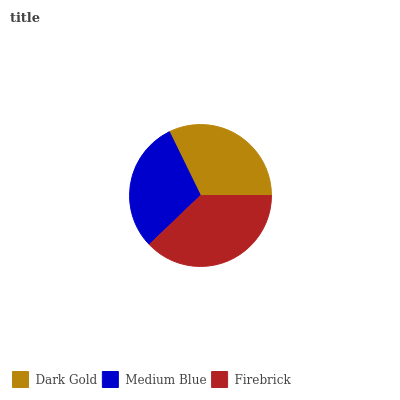Is Medium Blue the minimum?
Answer yes or no. Yes. Is Firebrick the maximum?
Answer yes or no. Yes. Is Firebrick the minimum?
Answer yes or no. No. Is Medium Blue the maximum?
Answer yes or no. No. Is Firebrick greater than Medium Blue?
Answer yes or no. Yes. Is Medium Blue less than Firebrick?
Answer yes or no. Yes. Is Medium Blue greater than Firebrick?
Answer yes or no. No. Is Firebrick less than Medium Blue?
Answer yes or no. No. Is Dark Gold the high median?
Answer yes or no. Yes. Is Dark Gold the low median?
Answer yes or no. Yes. Is Firebrick the high median?
Answer yes or no. No. Is Medium Blue the low median?
Answer yes or no. No. 